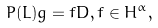<formula> <loc_0><loc_0><loc_500><loc_500>P ( L ) g = f D , f \in H ^ { \alpha } ,</formula> 